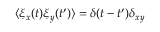Convert formula to latex. <formula><loc_0><loc_0><loc_500><loc_500>\langle \xi _ { x } ( t ) \xi _ { y } ( t ^ { \prime } ) \rangle = \delta ( t - t ^ { \prime } ) \delta _ { x y }</formula> 